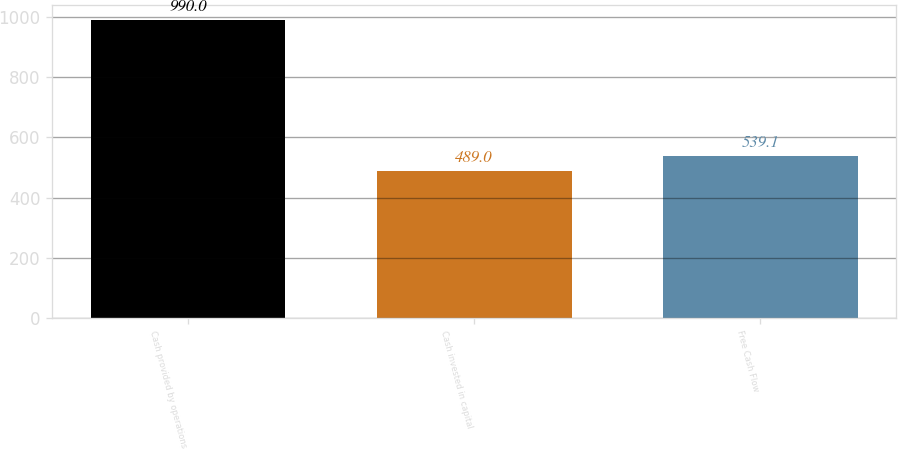Convert chart to OTSL. <chart><loc_0><loc_0><loc_500><loc_500><bar_chart><fcel>Cash provided by operations<fcel>Cash invested in capital<fcel>Free Cash Flow<nl><fcel>990<fcel>489<fcel>539.1<nl></chart> 